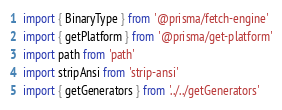<code> <loc_0><loc_0><loc_500><loc_500><_TypeScript_>import { BinaryType } from '@prisma/fetch-engine'
import { getPlatform } from '@prisma/get-platform'
import path from 'path'
import stripAnsi from 'strip-ansi'
import { getGenerators } from '../../getGenerators'</code> 